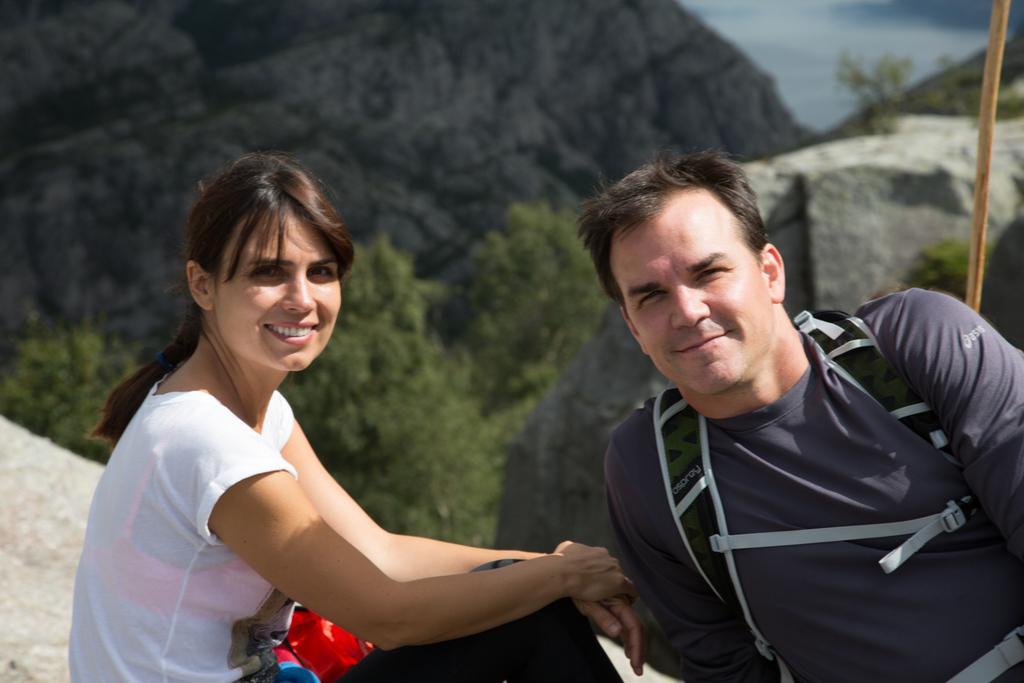Could you give a brief overview of what you see in this image? In this image, we can see persons wearing clothes. There are some trees and hills in the middle of the image. 